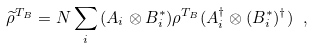Convert formula to latex. <formula><loc_0><loc_0><loc_500><loc_500>\widetilde { \rho } ^ { T _ { B } } = N \sum _ { i } { ( A _ { i } \otimes B _ { i } ^ { * } ) \rho ^ { T _ { B } } ( A _ { i } ^ { \dagger } \otimes ( B _ { i } ^ { * } ) ^ { \dagger } ) } \ ,</formula> 